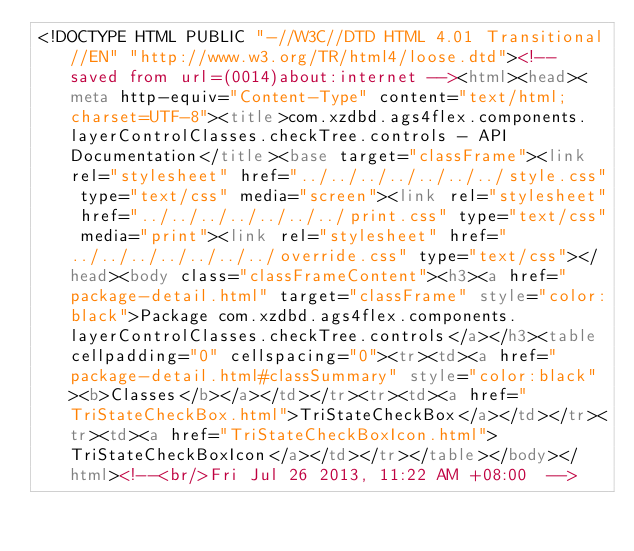Convert code to text. <code><loc_0><loc_0><loc_500><loc_500><_HTML_><!DOCTYPE HTML PUBLIC "-//W3C//DTD HTML 4.01 Transitional//EN" "http://www.w3.org/TR/html4/loose.dtd"><!-- saved from url=(0014)about:internet --><html><head><meta http-equiv="Content-Type" content="text/html; charset=UTF-8"><title>com.xzdbd.ags4flex.components.layerControlClasses.checkTree.controls - API Documentation</title><base target="classFrame"><link rel="stylesheet" href="../../../../../../../style.css" type="text/css" media="screen"><link rel="stylesheet" href="../../../../../../../print.css" type="text/css" media="print"><link rel="stylesheet" href="../../../../../../../override.css" type="text/css"></head><body class="classFrameContent"><h3><a href="package-detail.html" target="classFrame" style="color:black">Package com.xzdbd.ags4flex.components.layerControlClasses.checkTree.controls</a></h3><table cellpadding="0" cellspacing="0"><tr><td><a href="package-detail.html#classSummary" style="color:black"><b>Classes</b></a></td></tr><tr><td><a href="TriStateCheckBox.html">TriStateCheckBox</a></td></tr><tr><td><a href="TriStateCheckBoxIcon.html">TriStateCheckBoxIcon</a></td></tr></table></body></html><!--<br/>Fri Jul 26 2013, 11:22 AM +08:00  --></code> 